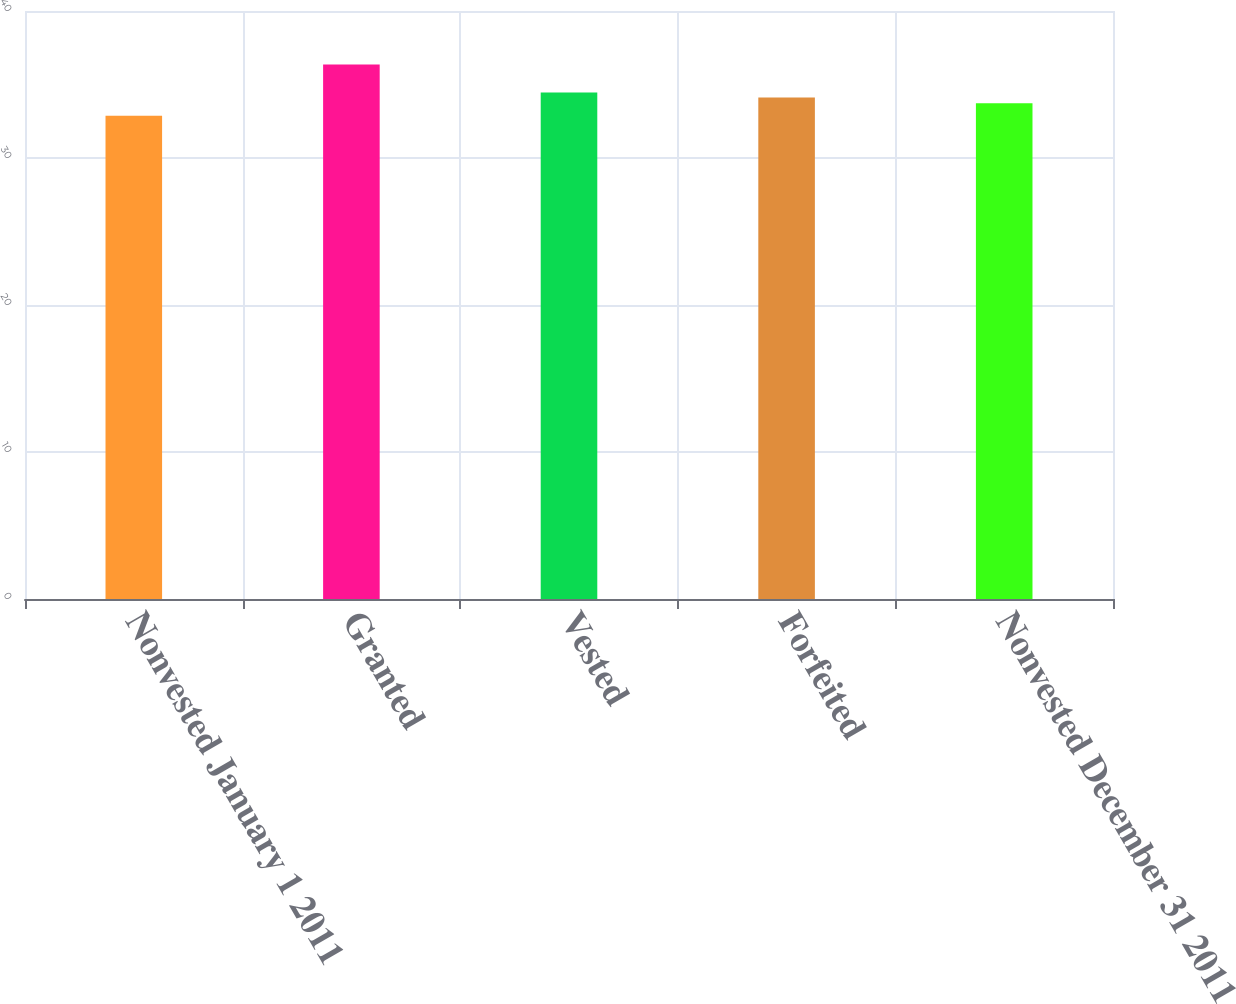<chart> <loc_0><loc_0><loc_500><loc_500><bar_chart><fcel>Nonvested January 1 2011<fcel>Granted<fcel>Vested<fcel>Forfeited<fcel>Nonvested December 31 2011<nl><fcel>32.88<fcel>36.36<fcel>34.46<fcel>34.11<fcel>33.73<nl></chart> 